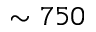Convert formula to latex. <formula><loc_0><loc_0><loc_500><loc_500>\sim 7 5 0</formula> 